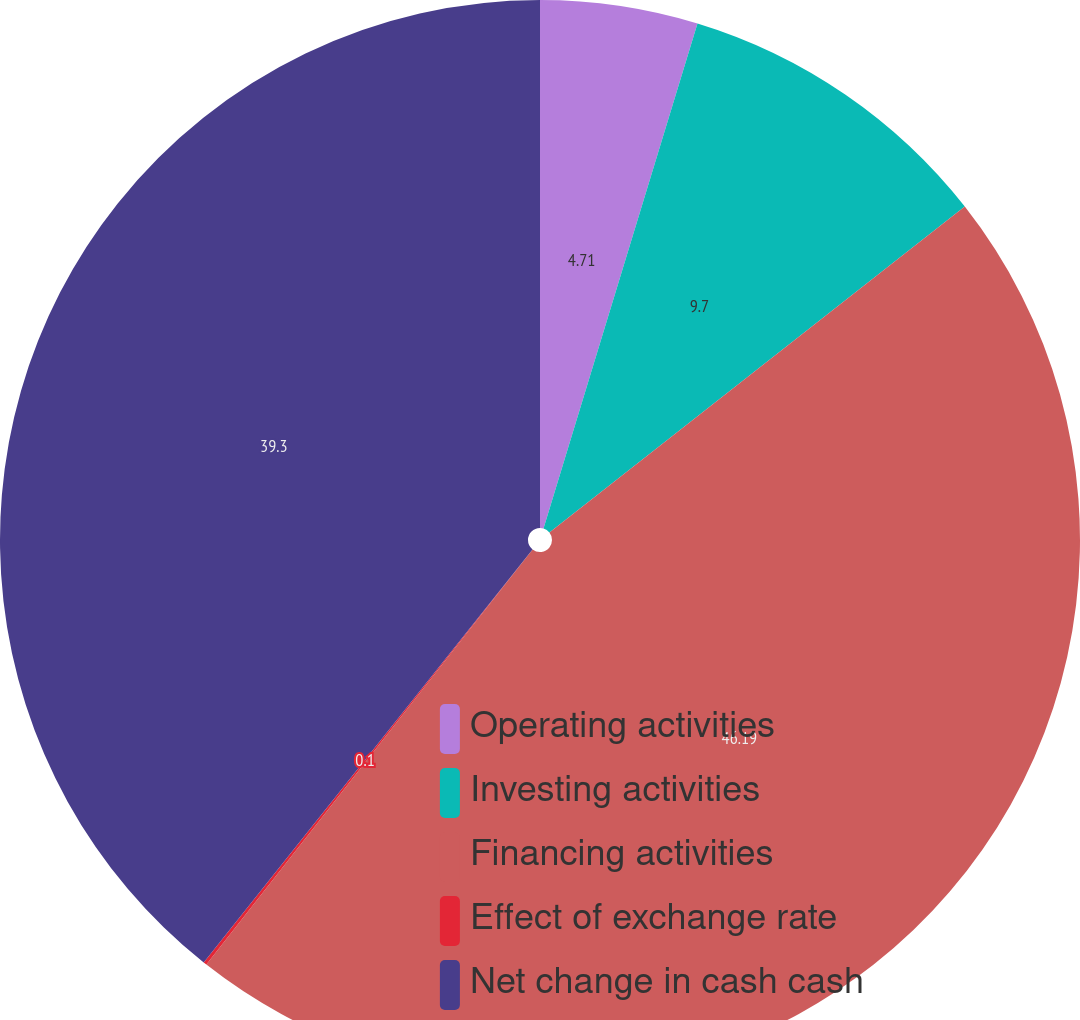Convert chart to OTSL. <chart><loc_0><loc_0><loc_500><loc_500><pie_chart><fcel>Operating activities<fcel>Investing activities<fcel>Financing activities<fcel>Effect of exchange rate<fcel>Net change in cash cash<nl><fcel>4.71%<fcel>9.7%<fcel>46.19%<fcel>0.1%<fcel>39.3%<nl></chart> 